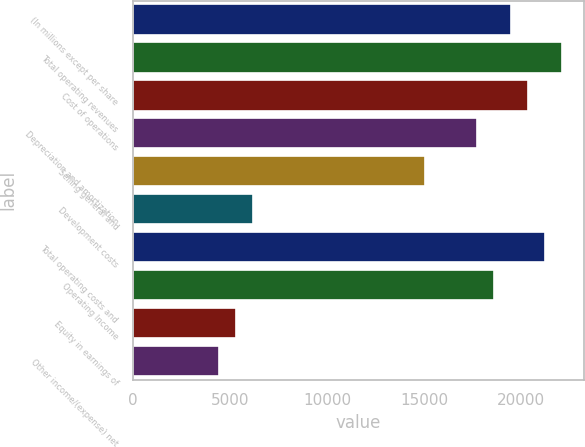Convert chart to OTSL. <chart><loc_0><loc_0><loc_500><loc_500><bar_chart><fcel>(In millions except per share<fcel>Total operating revenues<fcel>Cost of operations<fcel>Depreciation and amortization<fcel>Selling general and<fcel>Development costs<fcel>Total operating costs and<fcel>Operating Income<fcel>Equity in earnings of<fcel>Other income/(expense) net<nl><fcel>19465.7<fcel>22119.8<fcel>20350.4<fcel>17696.2<fcel>15042.1<fcel>6194.88<fcel>21235.1<fcel>18581<fcel>5310.16<fcel>4425.44<nl></chart> 